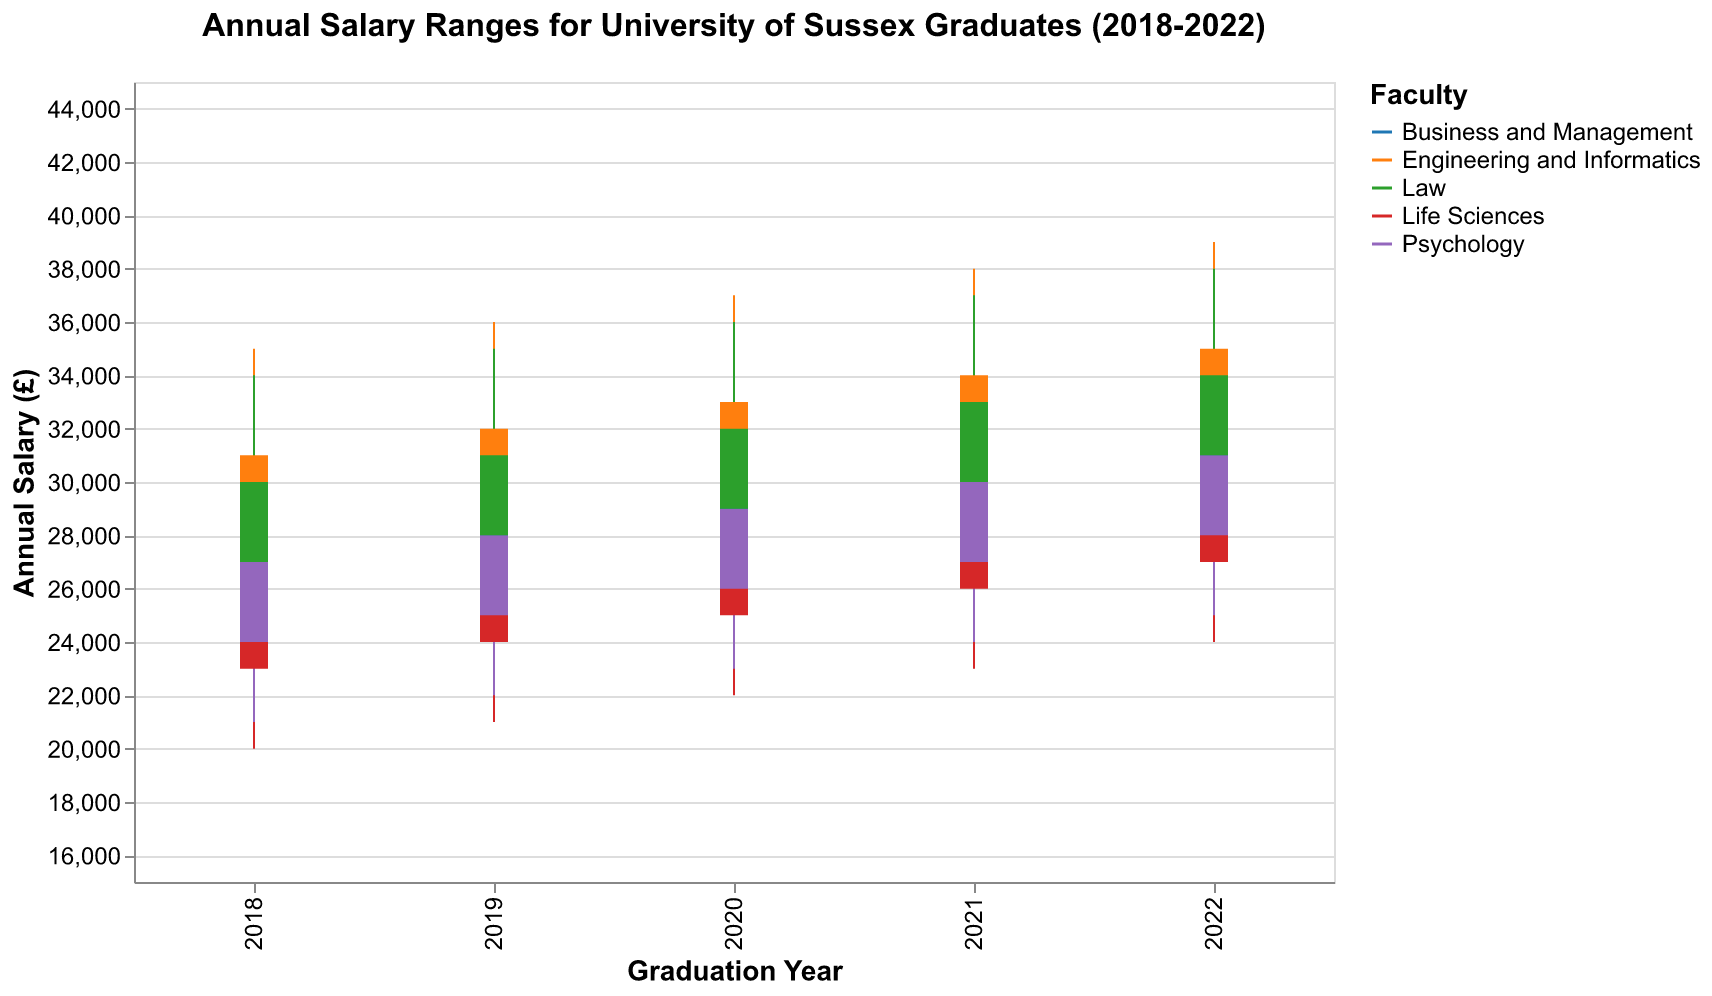What's the overall highest annual salary across all faculties and years in the data? The highest salary can be found by looking for the maximum value in the "High" column across all faculties and years. The highest annual salary is £39,000 observed for Engineering and Informatics in 2022.
Answer: £39,000 What is the difference in the closing salary for the Faculty of Business and Management between 2018 and 2022? To find the difference, subtract the closing salary in 2018 from the closing salary in 2022 for Business and Management. In 2018, the closing salary is £28,000 and in 2022 it is £32,000. So the difference is £32,000 - £28,000 = £4,000.
Answer: £4,000 Which faculty had the lowest range in salary in 2021? The salary range for each faculty in 2021 is found by subtracting the lowest salary from the highest salary. Compare the ranges (High - Low) for each faculty in 2021: Business and Management (£35,000 - £25,000 = £10,000), Engineering and Informatics (£38,000 - £28,000 = £10,000), Life Sciences (£33,000 - £23,000 = £10,000), Psychology (£34,000 - £24,000 = £10,000), Law (£37,000 - £27,000 = £10,000). All faculties had the same range of £10,000 in 2021.
Answer: All faculties had the same range (£10,000) Which faculty had the highest average high salary across the five years? The average high salary for each faculty over five years is calculated: Business and Management ((£32,000 + £33,000 + £34,000 + £35,000 + £36,000) / 5 = £34,000), Engineering and Informatics ((£35,000 + £36,000 + £37,000 + £38,000 + £39,000) / 5 = £37,000), Life Sciences ((£30,000 + £31,000 + £32,000 + £33,000 + £34,000) / 5 = £32,000), Psychology ((£31,000 + £32,000 + £33,000 + £34,000 + £35,000) / 5 = £33,000), Law ((£34,000 + £35,000 + £36,000 + £37,000 + £38,000) / 5 = £36,000). The highest average high salary is for Engineering and Informatics at £37,000.
Answer: Engineering and Informatics In which year did Psychology graduates have their highest low salary? Look at the low salary for Psychology graduates across all years and find the maximum. The low salary in 2022 is £25,000, which is higher than the low salaries in previous years (2018 - £21,000, 2019 - £22,000, 2020 - £23,000, 2021 - £24,000).
Answer: 2022 What is the average closing salary for Life Sciences over the five years? Add the closing salaries for Life Sciences for each year and divide by 5: (£26,000 + £27,000 + £28,000 + £29,000 + £30,000) / 5 = £28,000.
Answer: £28,000 Did the closing salary for Law graduates increase every year? Check if the closing salary for Law increases every year from 2018 to 2022: 2018 (£30,000), 2019 (£31,000), 2020 (£32,000), 2021 (£33,000), 2022 (£34,000). Since it increases every year, the answer is yes.
Answer: Yes 